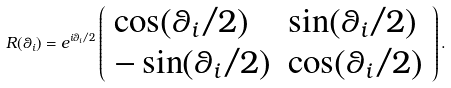Convert formula to latex. <formula><loc_0><loc_0><loc_500><loc_500>R ( \theta _ { i } ) = e ^ { i \theta _ { i } / 2 } \left ( \begin{array} { l l } \cos ( \theta _ { i } / 2 ) & \sin ( \theta _ { i } / 2 ) \\ - \sin ( \theta _ { i } / 2 ) & \cos ( \theta _ { i } / 2 ) \end{array} \right ) .</formula> 